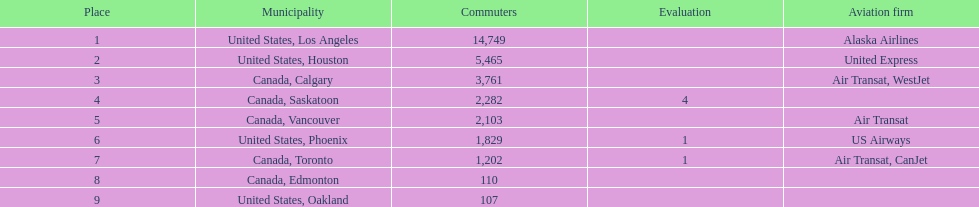Los angeles and what other city had about 19,000 passenger combined Canada, Calgary. 